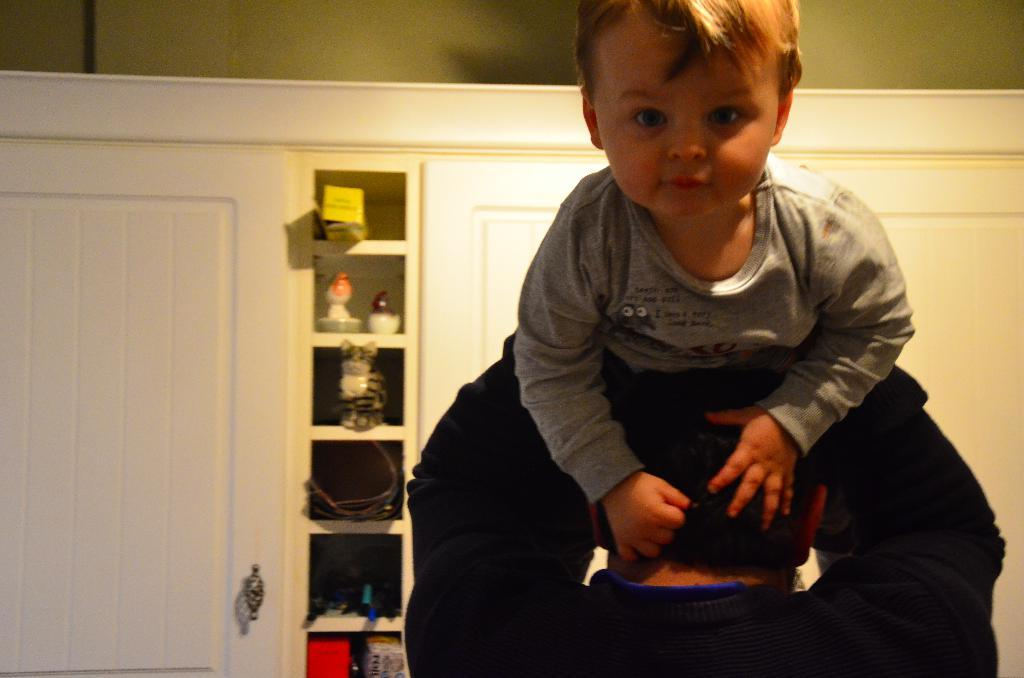What is the kid doing in the image? The kid is sitting on a person in the image. What else can be seen in the image besides the kid and the person? There are toys in the image. Where are the toys located? The toys are likely in the same area as the kid and the person. What else is visible in the image? There is a wall visible in the image. Can you describe the closet in the image? There are other objects in the closet in the image. How many goldfish are swimming in the closet in the image? There are no goldfish present in the image, and therefore no such activity can be observed. 